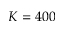<formula> <loc_0><loc_0><loc_500><loc_500>K = 4 0 0</formula> 